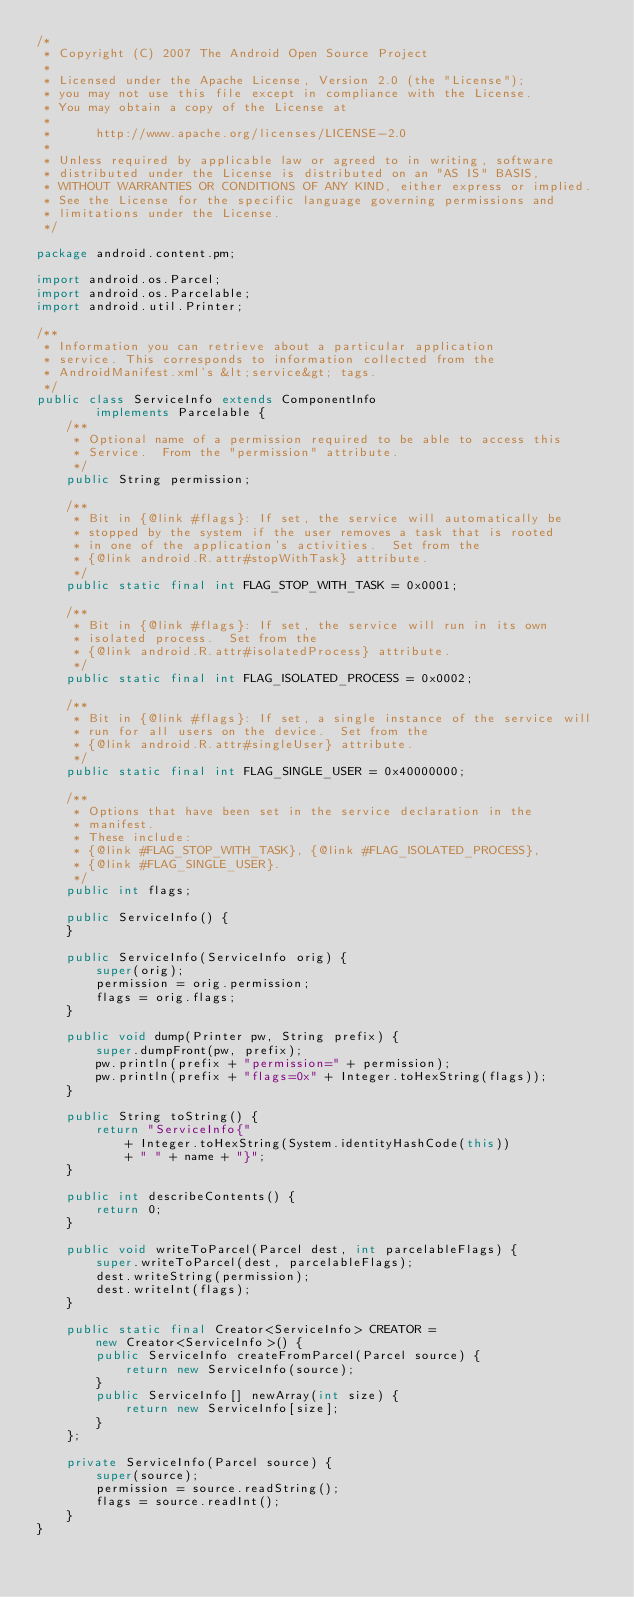Convert code to text. <code><loc_0><loc_0><loc_500><loc_500><_Java_>/*
 * Copyright (C) 2007 The Android Open Source Project
 *
 * Licensed under the Apache License, Version 2.0 (the "License");
 * you may not use this file except in compliance with the License.
 * You may obtain a copy of the License at
 *
 *      http://www.apache.org/licenses/LICENSE-2.0
 *
 * Unless required by applicable law or agreed to in writing, software
 * distributed under the License is distributed on an "AS IS" BASIS,
 * WITHOUT WARRANTIES OR CONDITIONS OF ANY KIND, either express or implied.
 * See the License for the specific language governing permissions and
 * limitations under the License.
 */

package android.content.pm;

import android.os.Parcel;
import android.os.Parcelable;
import android.util.Printer;

/**
 * Information you can retrieve about a particular application
 * service. This corresponds to information collected from the
 * AndroidManifest.xml's &lt;service&gt; tags.
 */
public class ServiceInfo extends ComponentInfo
        implements Parcelable {
    /**
     * Optional name of a permission required to be able to access this
     * Service.  From the "permission" attribute.
     */
    public String permission;

    /**
     * Bit in {@link #flags}: If set, the service will automatically be
     * stopped by the system if the user removes a task that is rooted
     * in one of the application's activities.  Set from the
     * {@link android.R.attr#stopWithTask} attribute.
     */
    public static final int FLAG_STOP_WITH_TASK = 0x0001;

    /**
     * Bit in {@link #flags}: If set, the service will run in its own
     * isolated process.  Set from the
     * {@link android.R.attr#isolatedProcess} attribute.
     */
    public static final int FLAG_ISOLATED_PROCESS = 0x0002;

    /**
     * Bit in {@link #flags}: If set, a single instance of the service will
     * run for all users on the device.  Set from the
     * {@link android.R.attr#singleUser} attribute.
     */
    public static final int FLAG_SINGLE_USER = 0x40000000;

    /**
     * Options that have been set in the service declaration in the
     * manifest.
     * These include:
     * {@link #FLAG_STOP_WITH_TASK}, {@link #FLAG_ISOLATED_PROCESS},
     * {@link #FLAG_SINGLE_USER}.
     */
    public int flags;

    public ServiceInfo() {
    }

    public ServiceInfo(ServiceInfo orig) {
        super(orig);
        permission = orig.permission;
        flags = orig.flags;
    }

    public void dump(Printer pw, String prefix) {
        super.dumpFront(pw, prefix);
        pw.println(prefix + "permission=" + permission);
        pw.println(prefix + "flags=0x" + Integer.toHexString(flags));
    }
    
    public String toString() {
        return "ServiceInfo{"
            + Integer.toHexString(System.identityHashCode(this))
            + " " + name + "}";
    }

    public int describeContents() {
        return 0;
    }

    public void writeToParcel(Parcel dest, int parcelableFlags) {
        super.writeToParcel(dest, parcelableFlags);
        dest.writeString(permission);
        dest.writeInt(flags);
    }

    public static final Creator<ServiceInfo> CREATOR =
        new Creator<ServiceInfo>() {
        public ServiceInfo createFromParcel(Parcel source) {
            return new ServiceInfo(source);
        }
        public ServiceInfo[] newArray(int size) {
            return new ServiceInfo[size];
        }
    };

    private ServiceInfo(Parcel source) {
        super(source);
        permission = source.readString();
        flags = source.readInt();
    }
}
</code> 